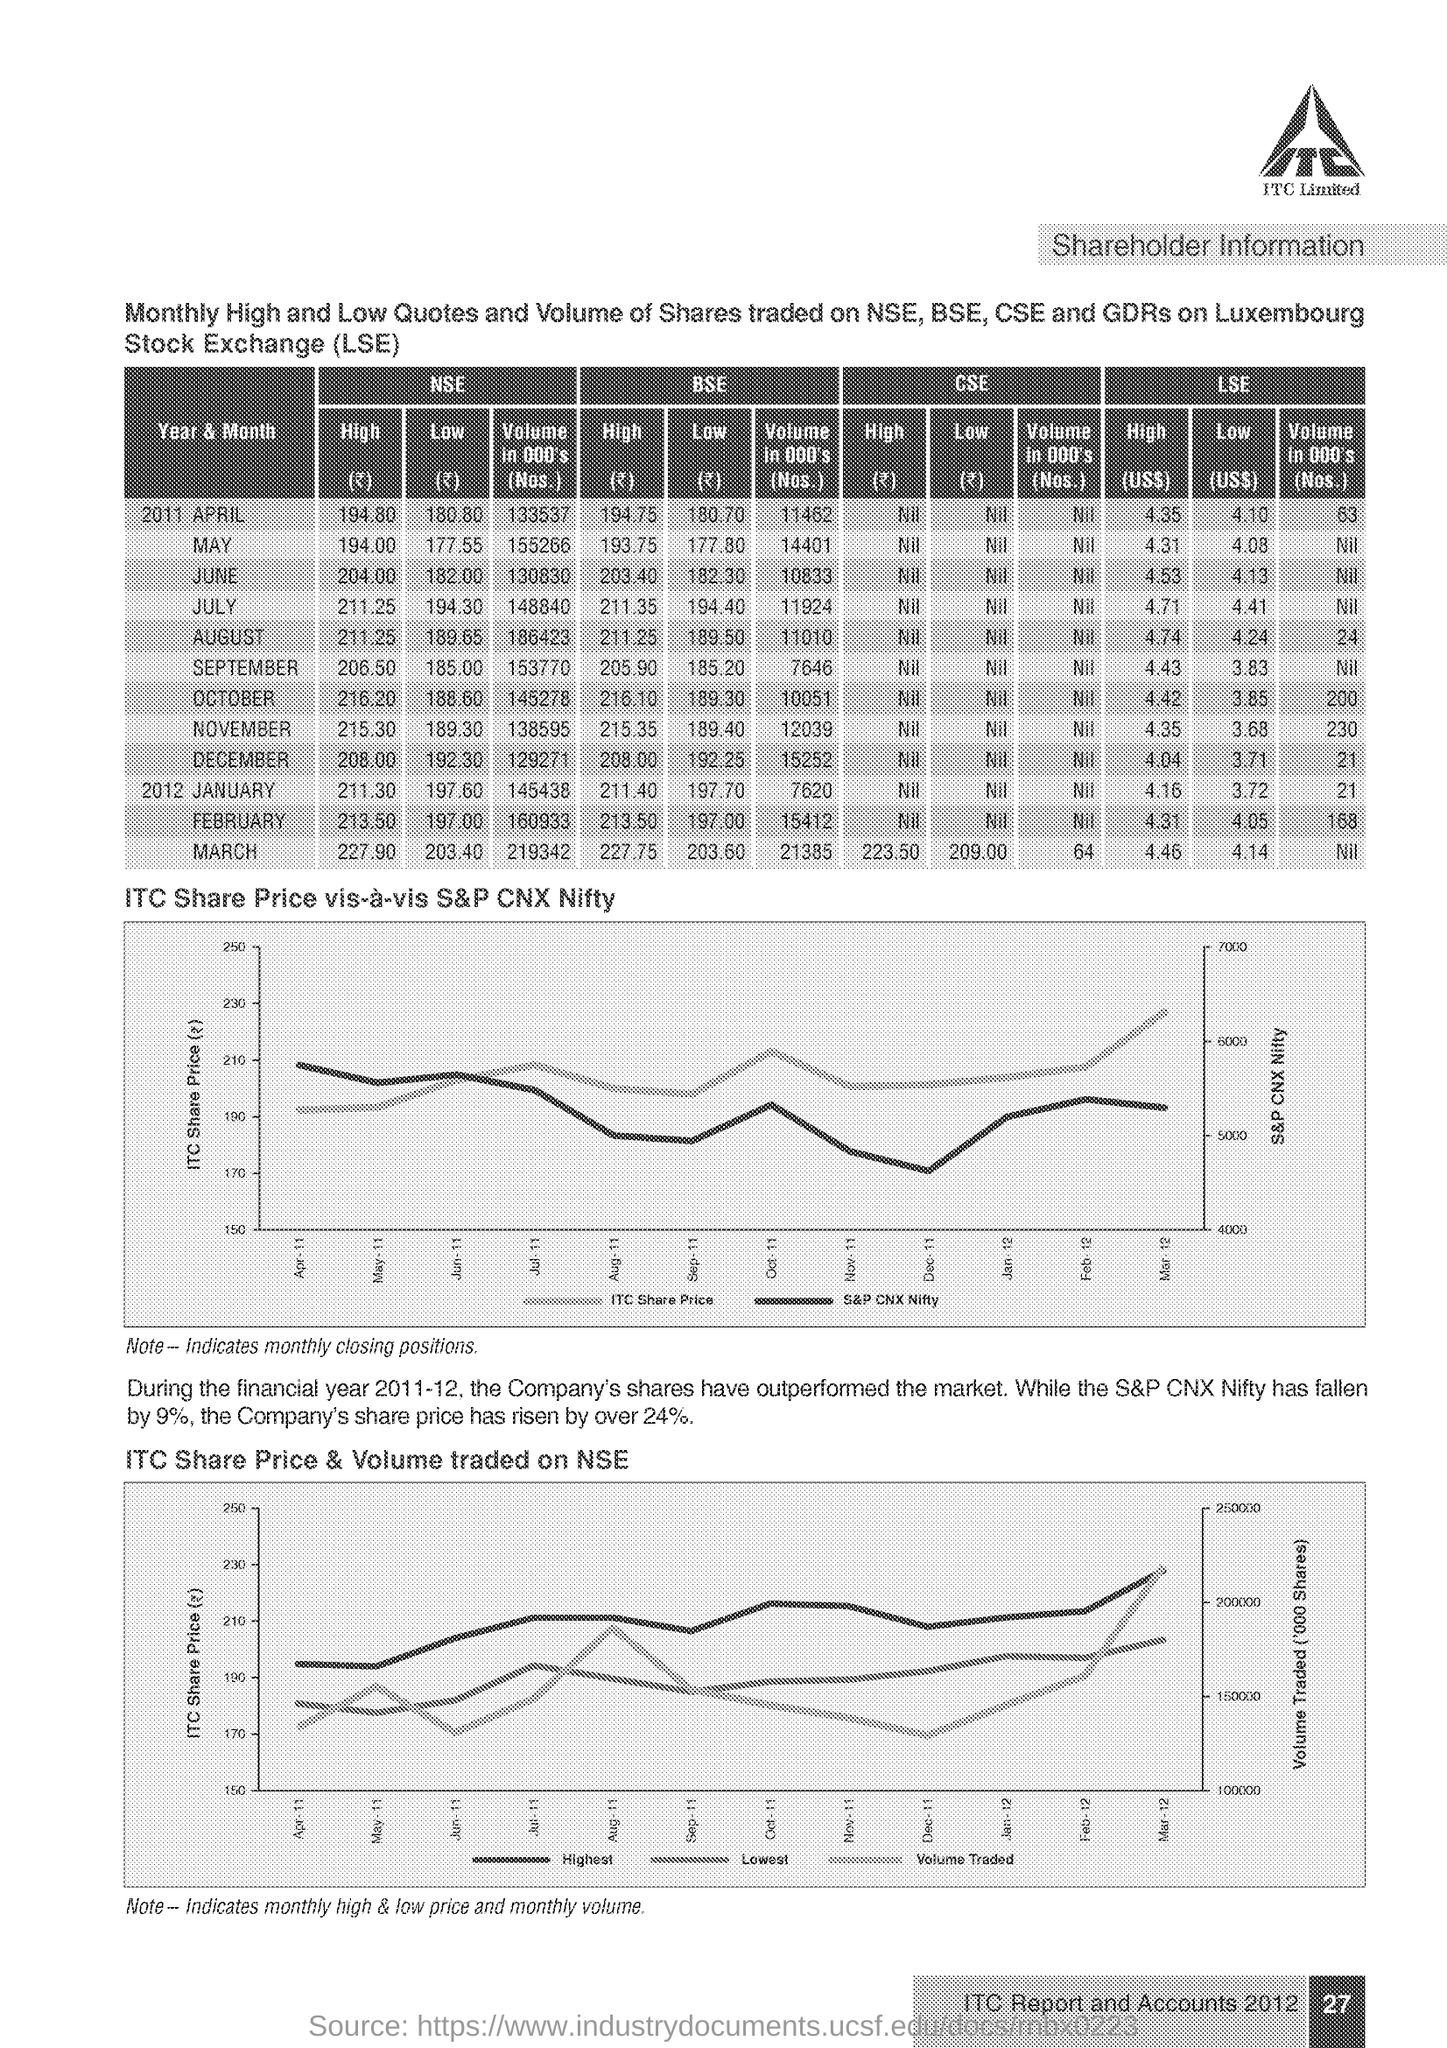Which company logo is this?(see right top corner of the page)
Provide a succinct answer. ITC Limited. What is written within the logo?
Keep it short and to the point. ITC. What is the expansion of LSE?
Offer a very short reply. Luxembourg Stock Exchange. What heading is given below "ITC Limited"?
Keep it short and to the point. Shareholder Information. Mention the "volume" of shares traded on NSE in the "Year and Month"  of  "2011 April"?
Give a very brief answer. 133537. Mention the "LOW" Quote of share traded on BSE in the "Year and Month"  of 2011 OCTOBER?
Your answer should be compact. 189.30. In the "ITC Share Price vis-a-vis S&P CNX Nifty" graph, what is on Y-axis on the left side?
Your answer should be compact. ITC Share Price. What is the title of the last graph?
Provide a succinct answer. ITC Share Price & Volume traded on NSE. Mention the page number given at the right bottom corner of the page?
Provide a short and direct response. 27. 